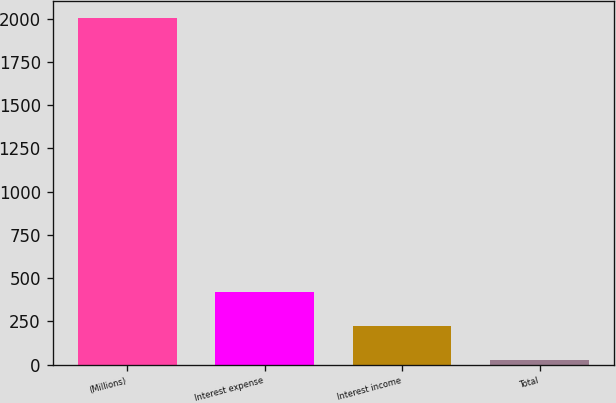<chart> <loc_0><loc_0><loc_500><loc_500><bar_chart><fcel>(Millions)<fcel>Interest expense<fcel>Interest income<fcel>Total<nl><fcel>2005<fcel>421.8<fcel>223.9<fcel>26<nl></chart> 